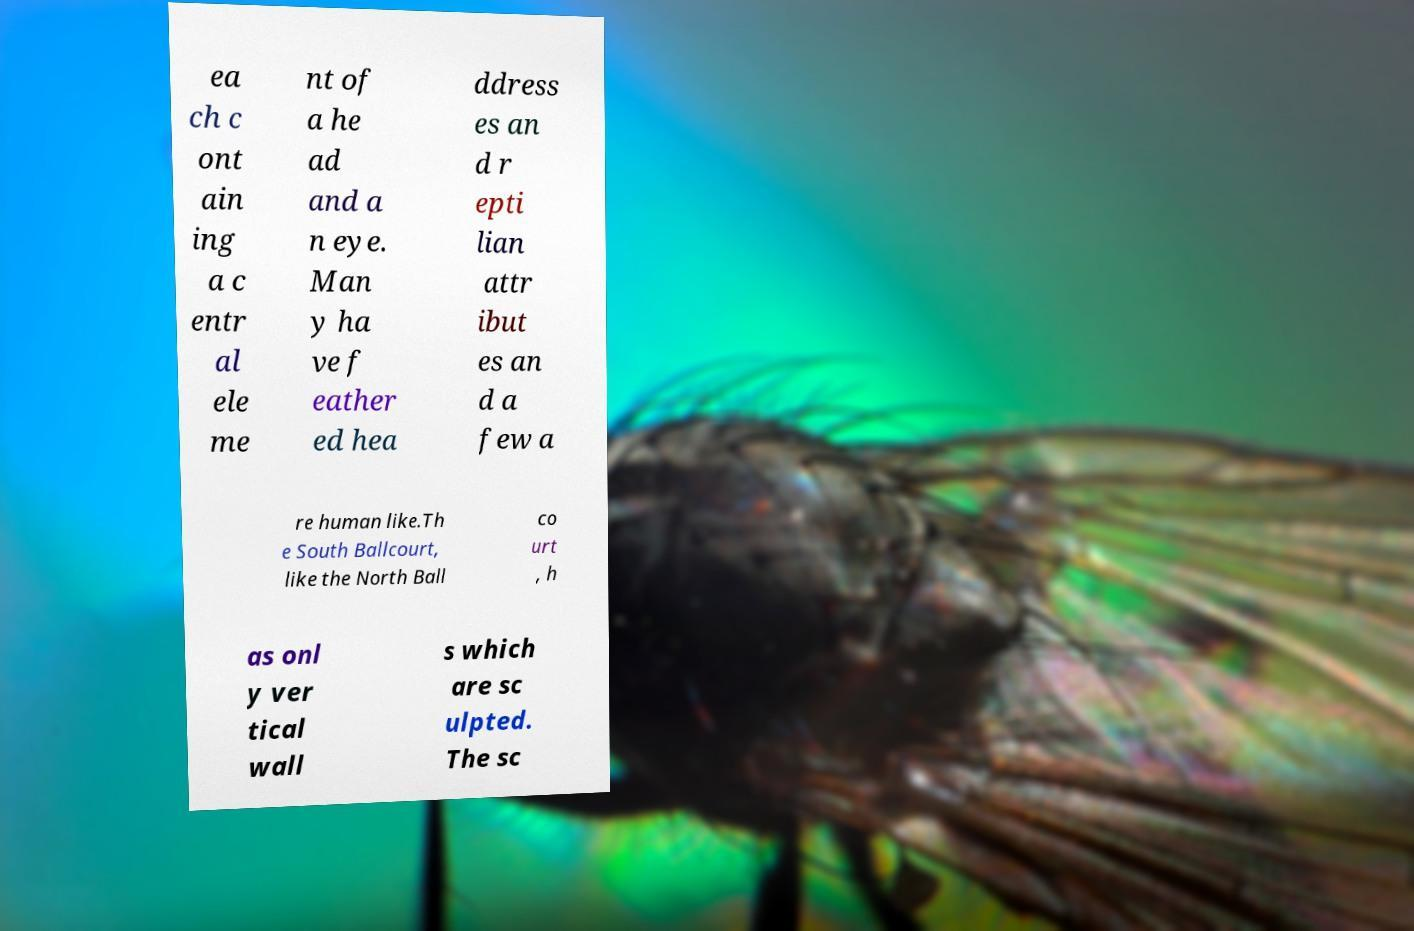Can you accurately transcribe the text from the provided image for me? ea ch c ont ain ing a c entr al ele me nt of a he ad and a n eye. Man y ha ve f eather ed hea ddress es an d r epti lian attr ibut es an d a few a re human like.Th e South Ballcourt, like the North Ball co urt , h as onl y ver tical wall s which are sc ulpted. The sc 